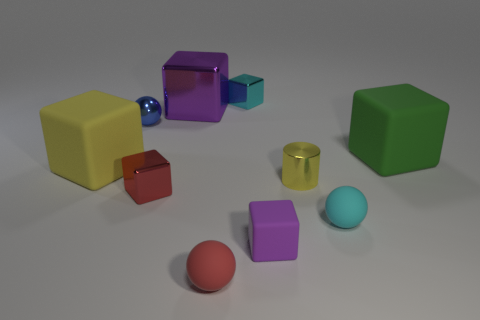Subtract all purple cylinders. How many purple blocks are left? 2 Subtract all small metal cubes. How many cubes are left? 4 Subtract all purple cubes. How many cubes are left? 4 Subtract all gray cubes. Subtract all purple spheres. How many cubes are left? 6 Subtract all cylinders. How many objects are left? 9 Subtract all matte cylinders. Subtract all big yellow matte blocks. How many objects are left? 9 Add 6 small purple matte cubes. How many small purple matte cubes are left? 7 Add 2 small yellow things. How many small yellow things exist? 3 Subtract 0 brown cylinders. How many objects are left? 10 